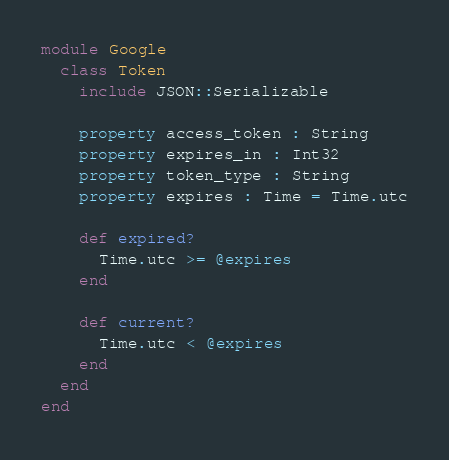Convert code to text. <code><loc_0><loc_0><loc_500><loc_500><_Crystal_>module Google
  class Token
    include JSON::Serializable

    property access_token : String
    property expires_in : Int32
    property token_type : String
    property expires : Time = Time.utc

    def expired?
      Time.utc >= @expires
    end

    def current?
      Time.utc < @expires
    end
  end
end
</code> 